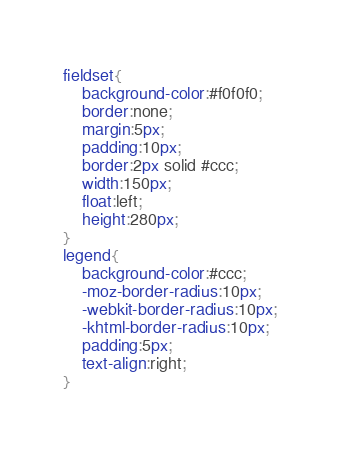Convert code to text. <code><loc_0><loc_0><loc_500><loc_500><_CSS_>fieldset{
    background-color:#f0f0f0;
    border:none;
    margin:5px;
    padding:10px;
    border:2px solid #ccc;
    width:150px;
    float:left;
    height:280px;
}
legend{
    background-color:#ccc;
    -moz-border-radius:10px;
    -webkit-border-radius:10px;
    -khtml-border-radius:10px;
    padding:5px;
    text-align:right;
}</code> 